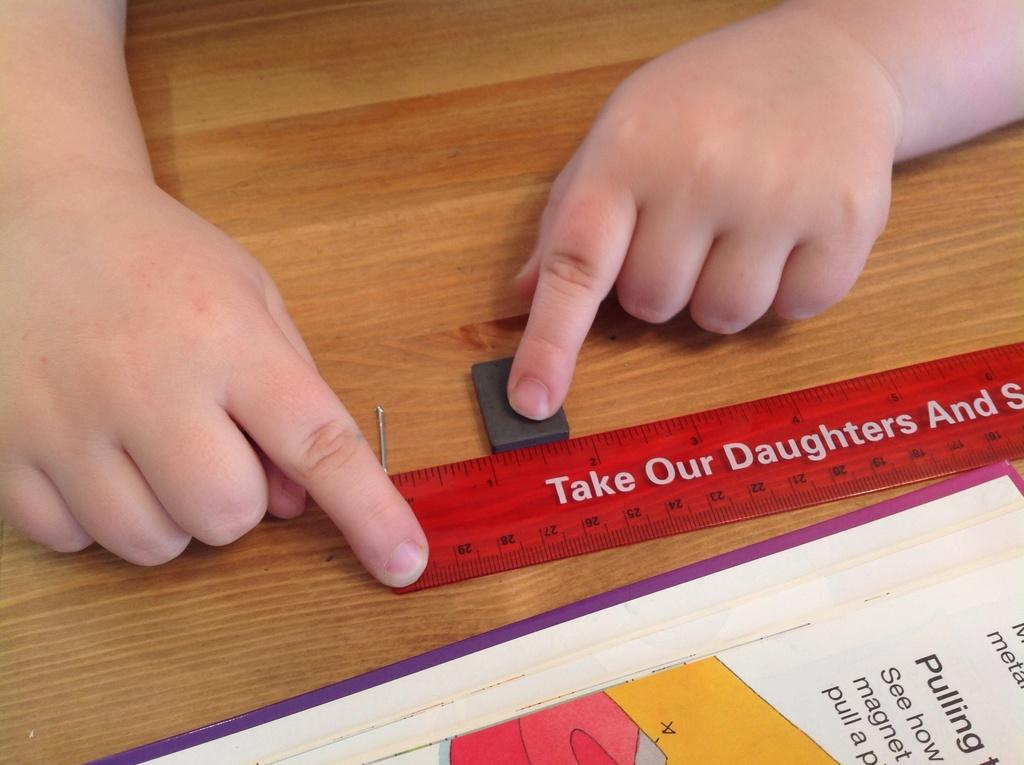<image>
Write a terse but informative summary of the picture. A young child uses a ruler to measure blocks that fit between 1 and 2 inches. 